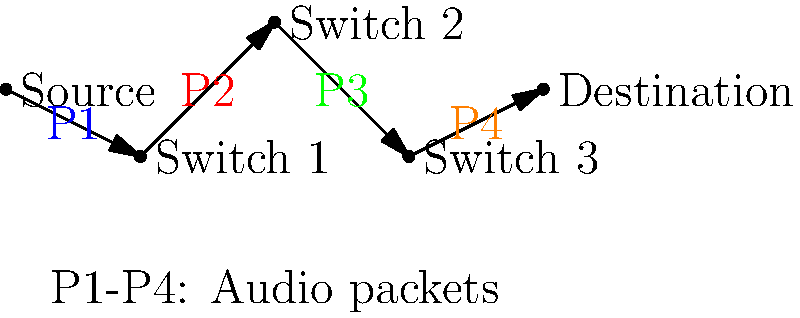In the diagram, how many switches does each audio packet pass through before reaching the destination, and how does this relate to the concept of packet switching in digital audio streaming for a trap beat? To understand the concept of packet switching in digital audio streaming for a trap beat, let's break it down step-by-step:

1. Source: This represents your studio or recording setup where you create your trap beats.

2. Packets (P1, P2, P3, P4): These represent different parts of your audio stream. In a trap beat, these could be:
   P1: Bass line
   P2: Snare and hi-hat
   P3: Synth melody
   P4: Vocal samples or ad-libs

3. Switches: There are three switches in the diagram. Each switch represents a point in the network where the packets can be routed independently.

4. Path: Each packet travels from the source, through all three switches, to the destination.

5. Packet Switching: This method allows each part of your beat to be sent independently. This is crucial for trap music because:
   a) It allows for real-time streaming, essential for live performances or studio sessions.
   b) If one packet is delayed (e.g., heavy bass line), other elements can still get through.
   c) It's efficient for sending complex, multi-layered beats typical in trap music.

6. Destination: This could be a streaming service, a live venue's sound system, or a collaborator's studio.

In the diagram, each packet (P1, P2, P3, P4) passes through all three switches before reaching the destination. This routing flexibility is key to maintaining the tight, intricate rhythms and layered sounds characteristic of trap music, ensuring your beats hit hard and clear, no matter where they're being played.
Answer: 3 switches 